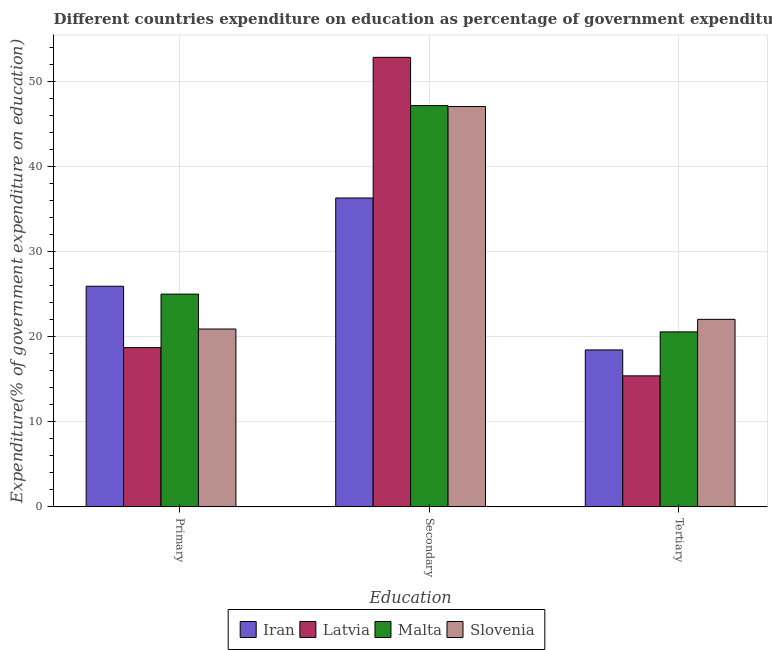How many different coloured bars are there?
Make the answer very short. 4. How many bars are there on the 3rd tick from the left?
Ensure brevity in your answer.  4. What is the label of the 3rd group of bars from the left?
Your response must be concise. Tertiary. What is the expenditure on secondary education in Latvia?
Make the answer very short. 52.87. Across all countries, what is the maximum expenditure on primary education?
Your answer should be very brief. 25.95. Across all countries, what is the minimum expenditure on tertiary education?
Keep it short and to the point. 15.41. In which country was the expenditure on primary education maximum?
Offer a terse response. Iran. In which country was the expenditure on secondary education minimum?
Keep it short and to the point. Iran. What is the total expenditure on tertiary education in the graph?
Give a very brief answer. 76.5. What is the difference between the expenditure on primary education in Slovenia and that in Malta?
Ensure brevity in your answer.  -4.11. What is the difference between the expenditure on secondary education in Iran and the expenditure on primary education in Latvia?
Give a very brief answer. 17.6. What is the average expenditure on primary education per country?
Offer a terse response. 22.65. What is the difference between the expenditure on tertiary education and expenditure on primary education in Iran?
Give a very brief answer. -7.49. What is the ratio of the expenditure on tertiary education in Slovenia to that in Iran?
Your answer should be very brief. 1.19. Is the expenditure on tertiary education in Iran less than that in Malta?
Your answer should be compact. Yes. What is the difference between the highest and the second highest expenditure on tertiary education?
Offer a very short reply. 1.47. What is the difference between the highest and the lowest expenditure on secondary education?
Ensure brevity in your answer.  16.54. Is the sum of the expenditure on primary education in Slovenia and Malta greater than the maximum expenditure on tertiary education across all countries?
Provide a succinct answer. Yes. What does the 1st bar from the left in Primary represents?
Provide a short and direct response. Iran. What does the 2nd bar from the right in Tertiary represents?
Ensure brevity in your answer.  Malta. How many countries are there in the graph?
Provide a short and direct response. 4. Does the graph contain any zero values?
Your response must be concise. No. Where does the legend appear in the graph?
Make the answer very short. Bottom center. How many legend labels are there?
Provide a short and direct response. 4. How are the legend labels stacked?
Your response must be concise. Horizontal. What is the title of the graph?
Your answer should be compact. Different countries expenditure on education as percentage of government expenditure. Does "Antigua and Barbuda" appear as one of the legend labels in the graph?
Provide a short and direct response. No. What is the label or title of the X-axis?
Your answer should be compact. Education. What is the label or title of the Y-axis?
Your answer should be very brief. Expenditure(% of government expenditure on education). What is the Expenditure(% of government expenditure on education) in Iran in Primary?
Offer a terse response. 25.95. What is the Expenditure(% of government expenditure on education) in Latvia in Primary?
Your answer should be very brief. 18.73. What is the Expenditure(% of government expenditure on education) in Malta in Primary?
Your response must be concise. 25.02. What is the Expenditure(% of government expenditure on education) of Slovenia in Primary?
Make the answer very short. 20.92. What is the Expenditure(% of government expenditure on education) of Iran in Secondary?
Provide a succinct answer. 36.33. What is the Expenditure(% of government expenditure on education) of Latvia in Secondary?
Keep it short and to the point. 52.87. What is the Expenditure(% of government expenditure on education) in Malta in Secondary?
Ensure brevity in your answer.  47.2. What is the Expenditure(% of government expenditure on education) in Slovenia in Secondary?
Provide a succinct answer. 47.08. What is the Expenditure(% of government expenditure on education) in Iran in Tertiary?
Your answer should be compact. 18.46. What is the Expenditure(% of government expenditure on education) in Latvia in Tertiary?
Keep it short and to the point. 15.41. What is the Expenditure(% of government expenditure on education) of Malta in Tertiary?
Your answer should be compact. 20.58. What is the Expenditure(% of government expenditure on education) in Slovenia in Tertiary?
Ensure brevity in your answer.  22.06. Across all Education, what is the maximum Expenditure(% of government expenditure on education) in Iran?
Provide a succinct answer. 36.33. Across all Education, what is the maximum Expenditure(% of government expenditure on education) of Latvia?
Your response must be concise. 52.87. Across all Education, what is the maximum Expenditure(% of government expenditure on education) of Malta?
Offer a very short reply. 47.2. Across all Education, what is the maximum Expenditure(% of government expenditure on education) of Slovenia?
Keep it short and to the point. 47.08. Across all Education, what is the minimum Expenditure(% of government expenditure on education) of Iran?
Make the answer very short. 18.46. Across all Education, what is the minimum Expenditure(% of government expenditure on education) of Latvia?
Provide a short and direct response. 15.41. Across all Education, what is the minimum Expenditure(% of government expenditure on education) of Malta?
Provide a succinct answer. 20.58. Across all Education, what is the minimum Expenditure(% of government expenditure on education) of Slovenia?
Provide a succinct answer. 20.92. What is the total Expenditure(% of government expenditure on education) in Iran in the graph?
Your response must be concise. 80.73. What is the total Expenditure(% of government expenditure on education) in Latvia in the graph?
Offer a terse response. 87.01. What is the total Expenditure(% of government expenditure on education) of Malta in the graph?
Ensure brevity in your answer.  92.8. What is the total Expenditure(% of government expenditure on education) in Slovenia in the graph?
Your response must be concise. 90.06. What is the difference between the Expenditure(% of government expenditure on education) in Iran in Primary and that in Secondary?
Offer a very short reply. -10.38. What is the difference between the Expenditure(% of government expenditure on education) in Latvia in Primary and that in Secondary?
Your answer should be compact. -34.14. What is the difference between the Expenditure(% of government expenditure on education) of Malta in Primary and that in Secondary?
Make the answer very short. -22.17. What is the difference between the Expenditure(% of government expenditure on education) of Slovenia in Primary and that in Secondary?
Give a very brief answer. -26.17. What is the difference between the Expenditure(% of government expenditure on education) in Iran in Primary and that in Tertiary?
Provide a short and direct response. 7.49. What is the difference between the Expenditure(% of government expenditure on education) in Latvia in Primary and that in Tertiary?
Your answer should be very brief. 3.32. What is the difference between the Expenditure(% of government expenditure on education) of Malta in Primary and that in Tertiary?
Ensure brevity in your answer.  4.44. What is the difference between the Expenditure(% of government expenditure on education) of Slovenia in Primary and that in Tertiary?
Your response must be concise. -1.14. What is the difference between the Expenditure(% of government expenditure on education) of Iran in Secondary and that in Tertiary?
Make the answer very short. 17.87. What is the difference between the Expenditure(% of government expenditure on education) of Latvia in Secondary and that in Tertiary?
Keep it short and to the point. 37.46. What is the difference between the Expenditure(% of government expenditure on education) of Malta in Secondary and that in Tertiary?
Provide a succinct answer. 26.61. What is the difference between the Expenditure(% of government expenditure on education) of Slovenia in Secondary and that in Tertiary?
Provide a short and direct response. 25.03. What is the difference between the Expenditure(% of government expenditure on education) of Iran in Primary and the Expenditure(% of government expenditure on education) of Latvia in Secondary?
Provide a short and direct response. -26.92. What is the difference between the Expenditure(% of government expenditure on education) of Iran in Primary and the Expenditure(% of government expenditure on education) of Malta in Secondary?
Provide a short and direct response. -21.25. What is the difference between the Expenditure(% of government expenditure on education) in Iran in Primary and the Expenditure(% of government expenditure on education) in Slovenia in Secondary?
Ensure brevity in your answer.  -21.14. What is the difference between the Expenditure(% of government expenditure on education) in Latvia in Primary and the Expenditure(% of government expenditure on education) in Malta in Secondary?
Give a very brief answer. -28.46. What is the difference between the Expenditure(% of government expenditure on education) of Latvia in Primary and the Expenditure(% of government expenditure on education) of Slovenia in Secondary?
Your answer should be compact. -28.35. What is the difference between the Expenditure(% of government expenditure on education) of Malta in Primary and the Expenditure(% of government expenditure on education) of Slovenia in Secondary?
Offer a very short reply. -22.06. What is the difference between the Expenditure(% of government expenditure on education) in Iran in Primary and the Expenditure(% of government expenditure on education) in Latvia in Tertiary?
Ensure brevity in your answer.  10.54. What is the difference between the Expenditure(% of government expenditure on education) in Iran in Primary and the Expenditure(% of government expenditure on education) in Malta in Tertiary?
Your answer should be compact. 5.36. What is the difference between the Expenditure(% of government expenditure on education) of Iran in Primary and the Expenditure(% of government expenditure on education) of Slovenia in Tertiary?
Offer a very short reply. 3.89. What is the difference between the Expenditure(% of government expenditure on education) in Latvia in Primary and the Expenditure(% of government expenditure on education) in Malta in Tertiary?
Provide a short and direct response. -1.85. What is the difference between the Expenditure(% of government expenditure on education) in Latvia in Primary and the Expenditure(% of government expenditure on education) in Slovenia in Tertiary?
Offer a very short reply. -3.33. What is the difference between the Expenditure(% of government expenditure on education) in Malta in Primary and the Expenditure(% of government expenditure on education) in Slovenia in Tertiary?
Your answer should be compact. 2.97. What is the difference between the Expenditure(% of government expenditure on education) of Iran in Secondary and the Expenditure(% of government expenditure on education) of Latvia in Tertiary?
Make the answer very short. 20.92. What is the difference between the Expenditure(% of government expenditure on education) in Iran in Secondary and the Expenditure(% of government expenditure on education) in Malta in Tertiary?
Ensure brevity in your answer.  15.75. What is the difference between the Expenditure(% of government expenditure on education) of Iran in Secondary and the Expenditure(% of government expenditure on education) of Slovenia in Tertiary?
Your response must be concise. 14.27. What is the difference between the Expenditure(% of government expenditure on education) of Latvia in Secondary and the Expenditure(% of government expenditure on education) of Malta in Tertiary?
Offer a very short reply. 32.29. What is the difference between the Expenditure(% of government expenditure on education) in Latvia in Secondary and the Expenditure(% of government expenditure on education) in Slovenia in Tertiary?
Ensure brevity in your answer.  30.81. What is the difference between the Expenditure(% of government expenditure on education) of Malta in Secondary and the Expenditure(% of government expenditure on education) of Slovenia in Tertiary?
Ensure brevity in your answer.  25.14. What is the average Expenditure(% of government expenditure on education) in Iran per Education?
Your response must be concise. 26.91. What is the average Expenditure(% of government expenditure on education) of Latvia per Education?
Ensure brevity in your answer.  29. What is the average Expenditure(% of government expenditure on education) in Malta per Education?
Give a very brief answer. 30.93. What is the average Expenditure(% of government expenditure on education) of Slovenia per Education?
Ensure brevity in your answer.  30.02. What is the difference between the Expenditure(% of government expenditure on education) of Iran and Expenditure(% of government expenditure on education) of Latvia in Primary?
Give a very brief answer. 7.22. What is the difference between the Expenditure(% of government expenditure on education) in Iran and Expenditure(% of government expenditure on education) in Malta in Primary?
Offer a terse response. 0.92. What is the difference between the Expenditure(% of government expenditure on education) in Iran and Expenditure(% of government expenditure on education) in Slovenia in Primary?
Make the answer very short. 5.03. What is the difference between the Expenditure(% of government expenditure on education) in Latvia and Expenditure(% of government expenditure on education) in Malta in Primary?
Offer a very short reply. -6.29. What is the difference between the Expenditure(% of government expenditure on education) in Latvia and Expenditure(% of government expenditure on education) in Slovenia in Primary?
Ensure brevity in your answer.  -2.19. What is the difference between the Expenditure(% of government expenditure on education) of Malta and Expenditure(% of government expenditure on education) of Slovenia in Primary?
Offer a terse response. 4.11. What is the difference between the Expenditure(% of government expenditure on education) of Iran and Expenditure(% of government expenditure on education) of Latvia in Secondary?
Your answer should be very brief. -16.54. What is the difference between the Expenditure(% of government expenditure on education) in Iran and Expenditure(% of government expenditure on education) in Malta in Secondary?
Your answer should be compact. -10.87. What is the difference between the Expenditure(% of government expenditure on education) in Iran and Expenditure(% of government expenditure on education) in Slovenia in Secondary?
Give a very brief answer. -10.76. What is the difference between the Expenditure(% of government expenditure on education) in Latvia and Expenditure(% of government expenditure on education) in Malta in Secondary?
Your response must be concise. 5.67. What is the difference between the Expenditure(% of government expenditure on education) of Latvia and Expenditure(% of government expenditure on education) of Slovenia in Secondary?
Your answer should be very brief. 5.79. What is the difference between the Expenditure(% of government expenditure on education) in Iran and Expenditure(% of government expenditure on education) in Latvia in Tertiary?
Your answer should be very brief. 3.05. What is the difference between the Expenditure(% of government expenditure on education) in Iran and Expenditure(% of government expenditure on education) in Malta in Tertiary?
Your response must be concise. -2.12. What is the difference between the Expenditure(% of government expenditure on education) of Iran and Expenditure(% of government expenditure on education) of Slovenia in Tertiary?
Give a very brief answer. -3.6. What is the difference between the Expenditure(% of government expenditure on education) of Latvia and Expenditure(% of government expenditure on education) of Malta in Tertiary?
Provide a succinct answer. -5.17. What is the difference between the Expenditure(% of government expenditure on education) of Latvia and Expenditure(% of government expenditure on education) of Slovenia in Tertiary?
Ensure brevity in your answer.  -6.65. What is the difference between the Expenditure(% of government expenditure on education) of Malta and Expenditure(% of government expenditure on education) of Slovenia in Tertiary?
Give a very brief answer. -1.47. What is the ratio of the Expenditure(% of government expenditure on education) in Iran in Primary to that in Secondary?
Offer a terse response. 0.71. What is the ratio of the Expenditure(% of government expenditure on education) in Latvia in Primary to that in Secondary?
Give a very brief answer. 0.35. What is the ratio of the Expenditure(% of government expenditure on education) in Malta in Primary to that in Secondary?
Provide a succinct answer. 0.53. What is the ratio of the Expenditure(% of government expenditure on education) in Slovenia in Primary to that in Secondary?
Keep it short and to the point. 0.44. What is the ratio of the Expenditure(% of government expenditure on education) of Iran in Primary to that in Tertiary?
Offer a terse response. 1.41. What is the ratio of the Expenditure(% of government expenditure on education) in Latvia in Primary to that in Tertiary?
Give a very brief answer. 1.22. What is the ratio of the Expenditure(% of government expenditure on education) of Malta in Primary to that in Tertiary?
Your answer should be compact. 1.22. What is the ratio of the Expenditure(% of government expenditure on education) in Slovenia in Primary to that in Tertiary?
Offer a very short reply. 0.95. What is the ratio of the Expenditure(% of government expenditure on education) of Iran in Secondary to that in Tertiary?
Make the answer very short. 1.97. What is the ratio of the Expenditure(% of government expenditure on education) of Latvia in Secondary to that in Tertiary?
Make the answer very short. 3.43. What is the ratio of the Expenditure(% of government expenditure on education) in Malta in Secondary to that in Tertiary?
Ensure brevity in your answer.  2.29. What is the ratio of the Expenditure(% of government expenditure on education) of Slovenia in Secondary to that in Tertiary?
Keep it short and to the point. 2.13. What is the difference between the highest and the second highest Expenditure(% of government expenditure on education) in Iran?
Your answer should be compact. 10.38. What is the difference between the highest and the second highest Expenditure(% of government expenditure on education) of Latvia?
Offer a very short reply. 34.14. What is the difference between the highest and the second highest Expenditure(% of government expenditure on education) in Malta?
Offer a terse response. 22.17. What is the difference between the highest and the second highest Expenditure(% of government expenditure on education) of Slovenia?
Your answer should be compact. 25.03. What is the difference between the highest and the lowest Expenditure(% of government expenditure on education) of Iran?
Ensure brevity in your answer.  17.87. What is the difference between the highest and the lowest Expenditure(% of government expenditure on education) in Latvia?
Ensure brevity in your answer.  37.46. What is the difference between the highest and the lowest Expenditure(% of government expenditure on education) in Malta?
Your answer should be compact. 26.61. What is the difference between the highest and the lowest Expenditure(% of government expenditure on education) of Slovenia?
Ensure brevity in your answer.  26.17. 